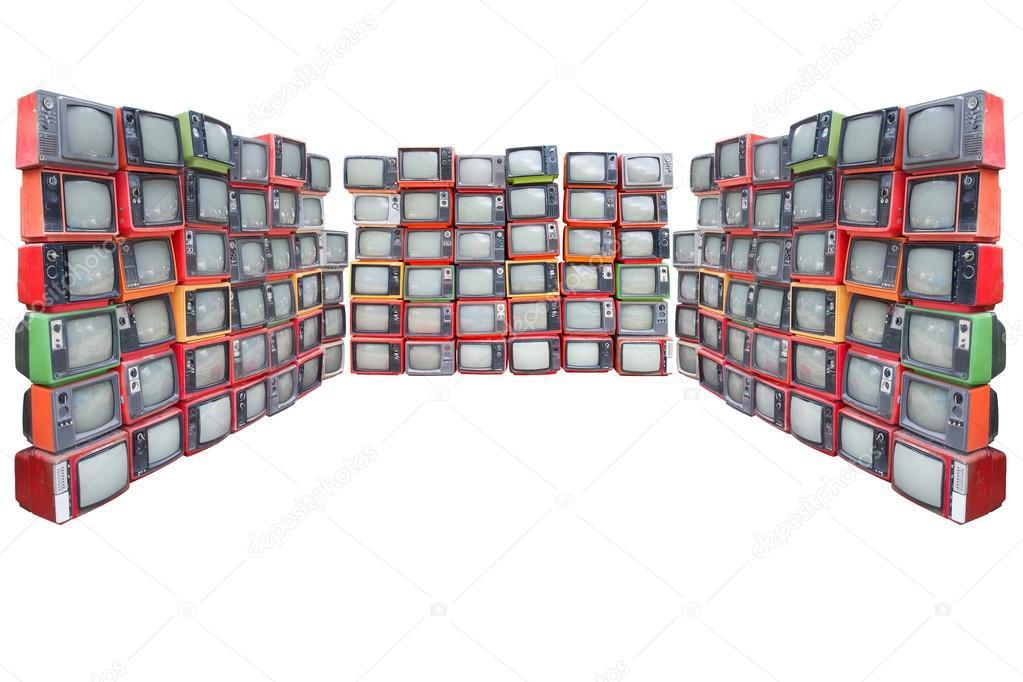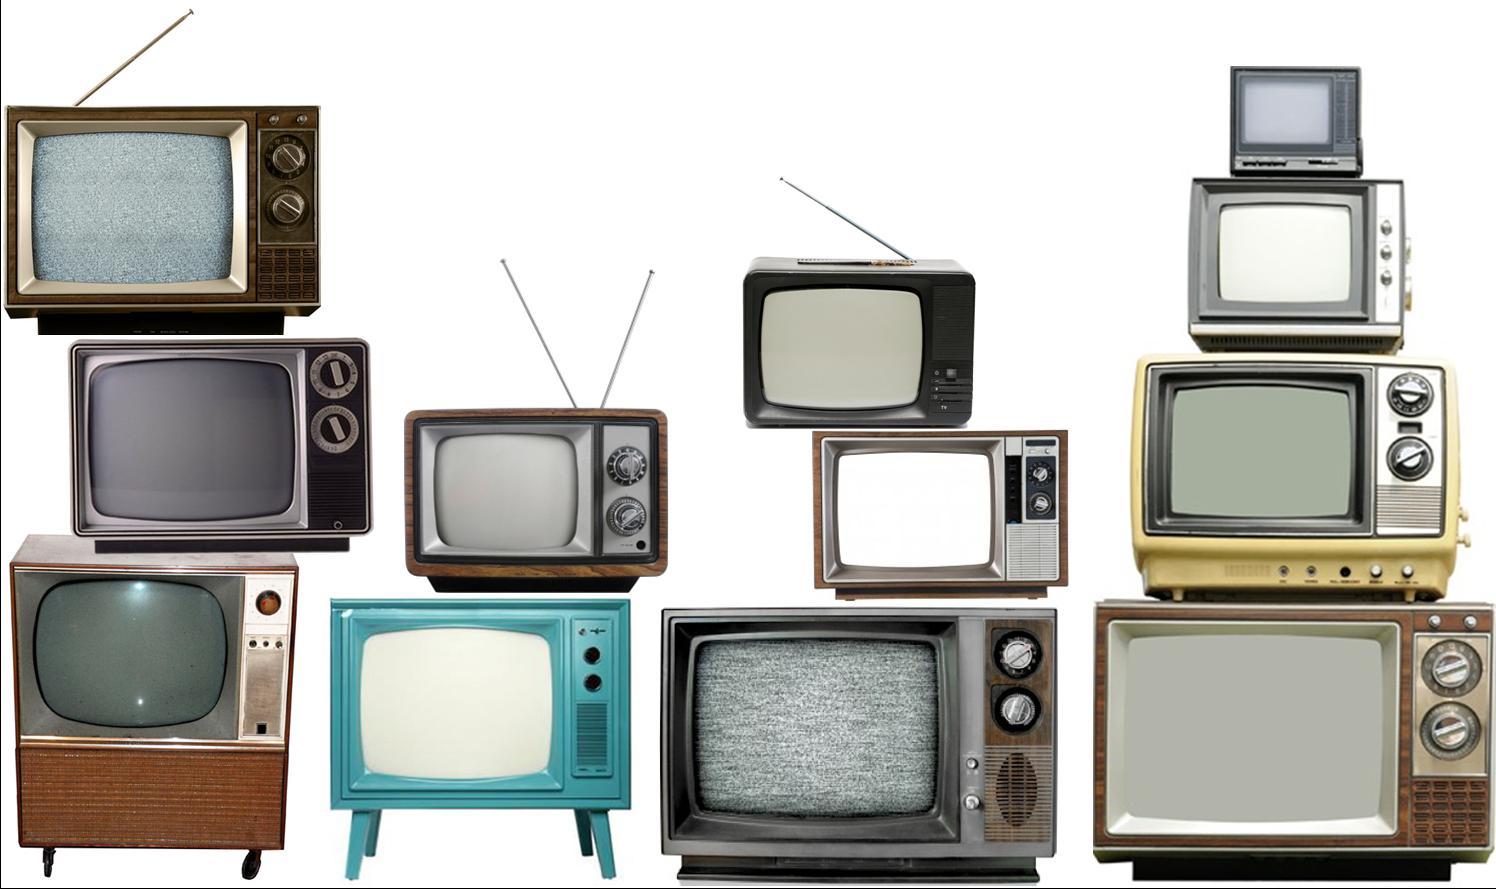The first image is the image on the left, the second image is the image on the right. Considering the images on both sides, is "In one of the images, there is only one television." valid? Answer yes or no. No. The first image is the image on the left, the second image is the image on the right. Evaluate the accuracy of this statement regarding the images: "Multiple colorful tv's are stacked on each other". Is it true? Answer yes or no. Yes. 